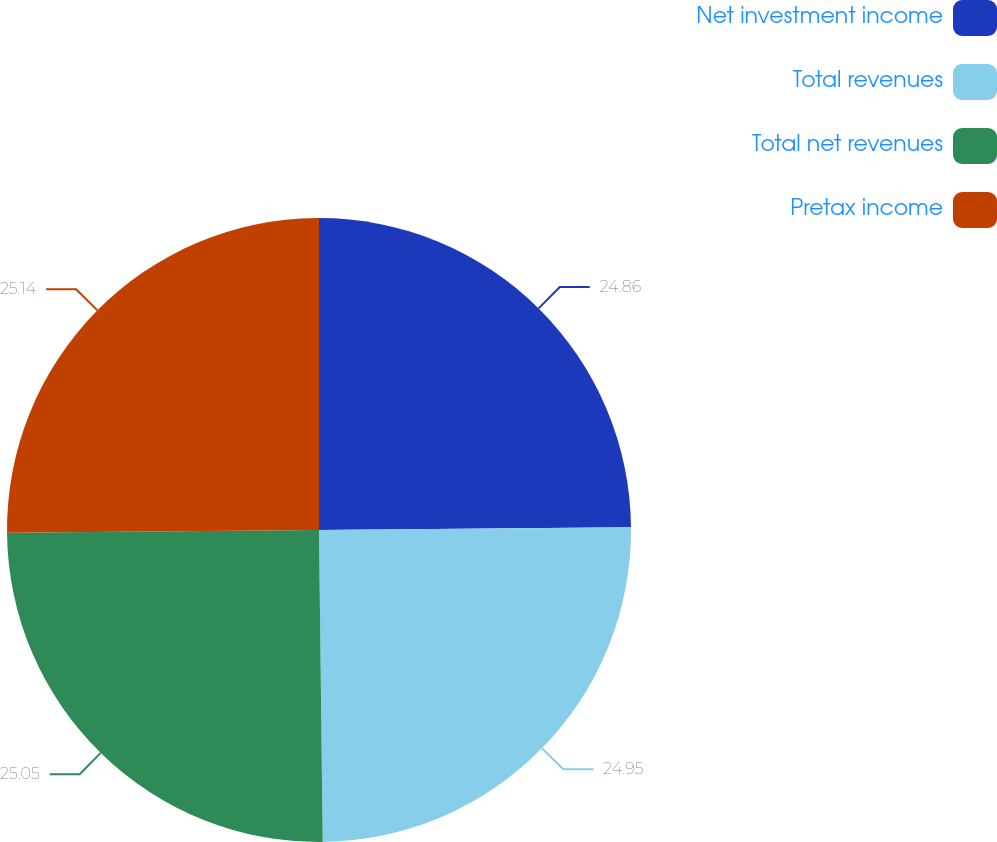Convert chart to OTSL. <chart><loc_0><loc_0><loc_500><loc_500><pie_chart><fcel>Net investment income<fcel>Total revenues<fcel>Total net revenues<fcel>Pretax income<nl><fcel>24.86%<fcel>24.95%<fcel>25.05%<fcel>25.14%<nl></chart> 